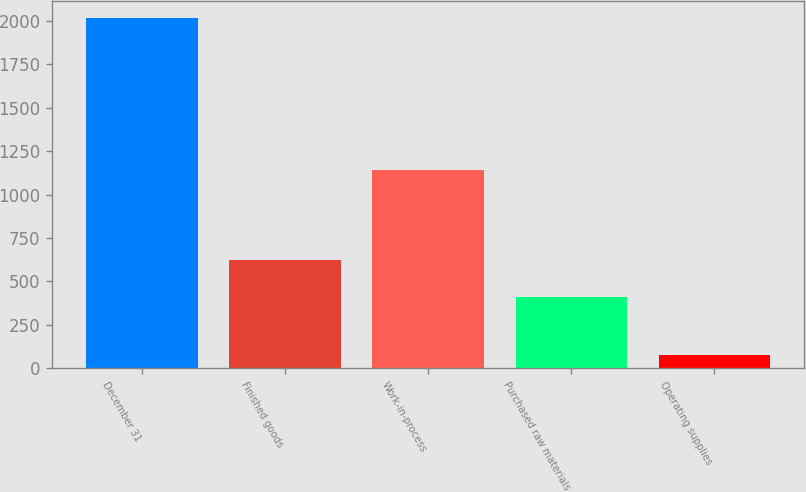Convert chart. <chart><loc_0><loc_0><loc_500><loc_500><bar_chart><fcel>December 31<fcel>Finished goods<fcel>Work-in-process<fcel>Purchased raw materials<fcel>Operating supplies<nl><fcel>2016<fcel>625<fcel>1144<fcel>408<fcel>76<nl></chart> 